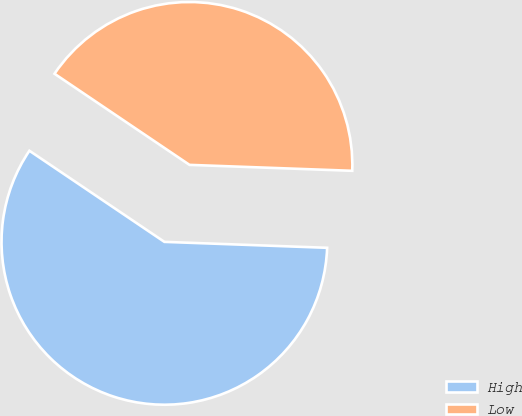Convert chart to OTSL. <chart><loc_0><loc_0><loc_500><loc_500><pie_chart><fcel>High<fcel>Low<nl><fcel>58.87%<fcel>41.13%<nl></chart> 